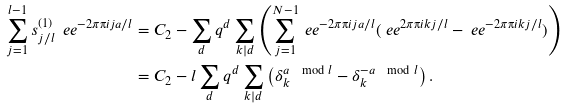<formula> <loc_0><loc_0><loc_500><loc_500>\sum _ { j = 1 } ^ { l - 1 } s _ { j / l } ^ { ( 1 ) } \ e e ^ { - 2 \pi \i i j a / l } & = C _ { 2 } - \sum _ { d } q ^ { d } \sum _ { k | d } \left ( \sum _ { j = 1 } ^ { N - 1 } \ e e ^ { - 2 \pi \i i j a / l } ( \ e e ^ { 2 \pi \i i k j / l } - \ e e ^ { - 2 \pi \i i k j / l } ) \right ) \\ & = C _ { 2 } - l \sum _ { d } q ^ { d } \sum _ { k | d } \left ( \delta _ { k } ^ { a \mod l } - \delta _ { k } ^ { - a \mod l } \right ) .</formula> 